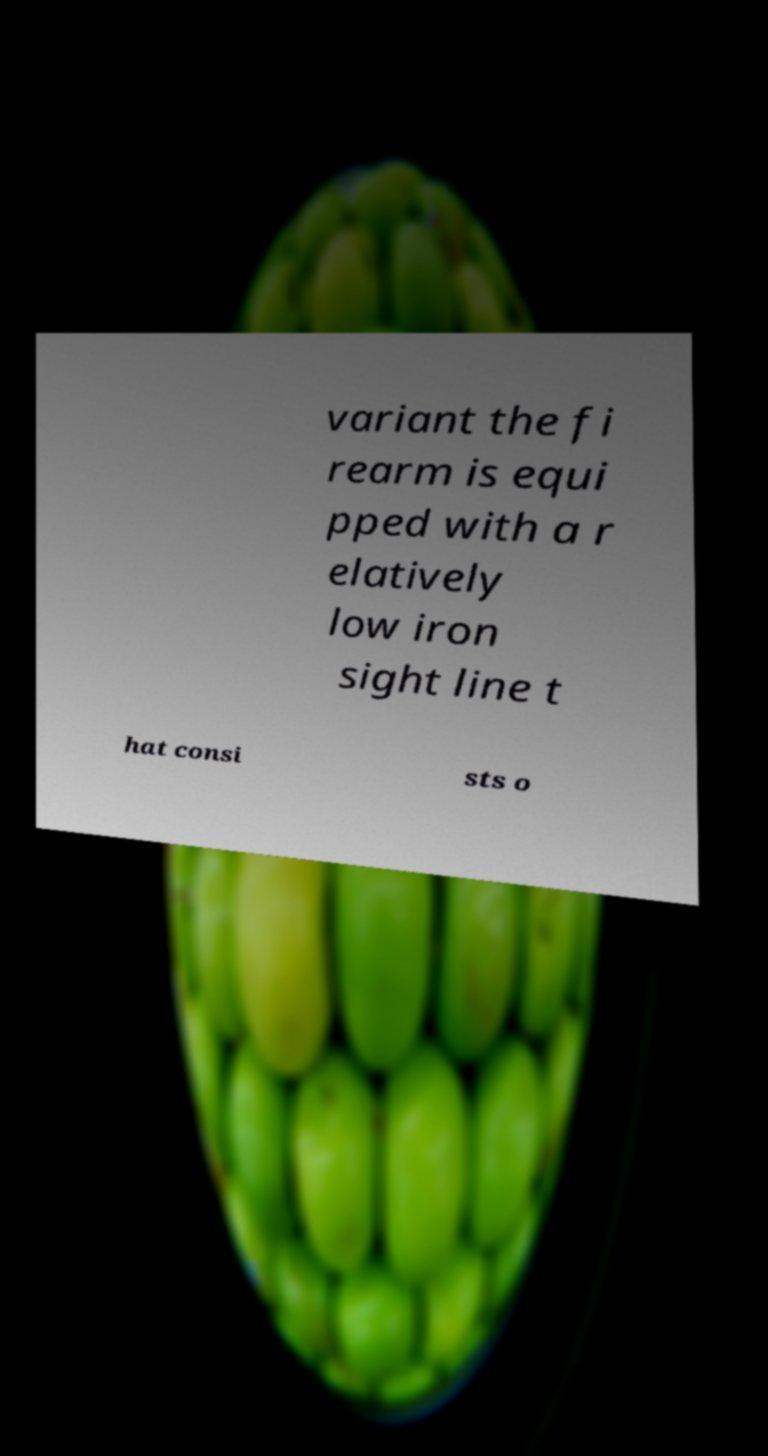Can you accurately transcribe the text from the provided image for me? variant the fi rearm is equi pped with a r elatively low iron sight line t hat consi sts o 